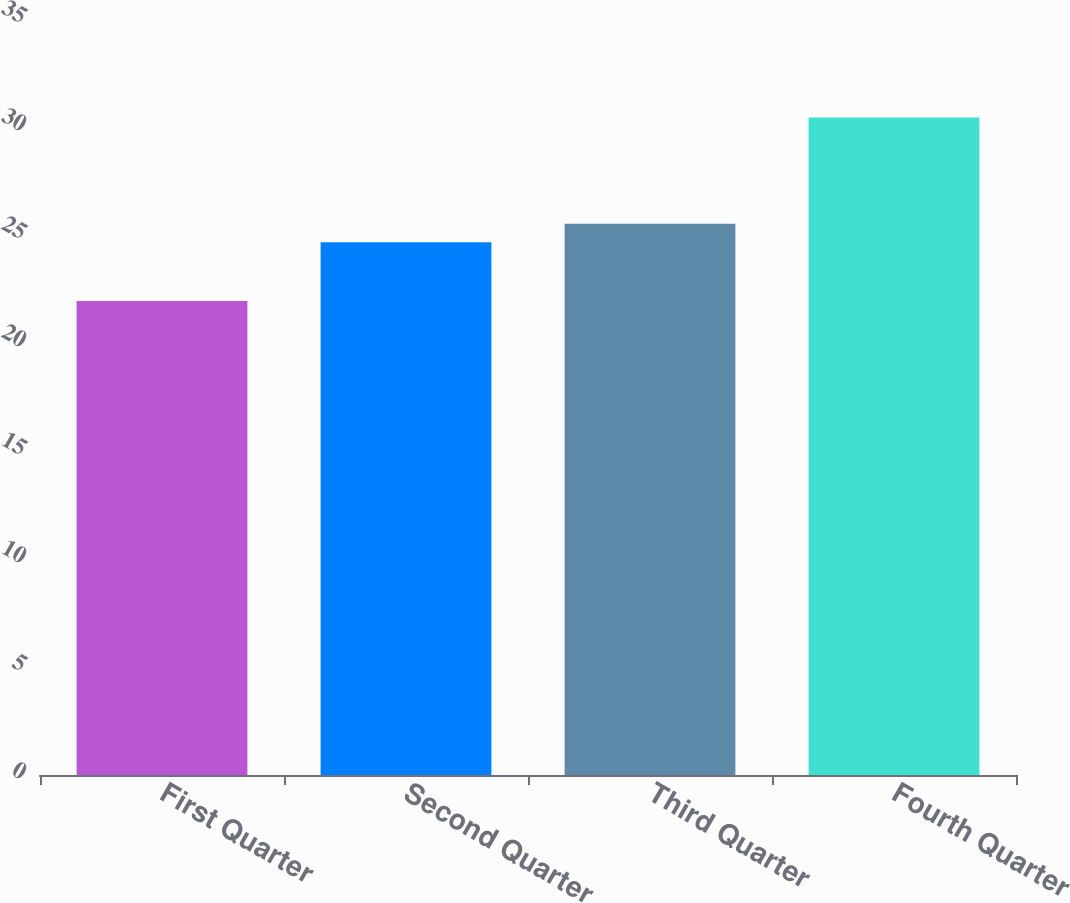Convert chart to OTSL. <chart><loc_0><loc_0><loc_500><loc_500><bar_chart><fcel>First Quarter<fcel>Second Quarter<fcel>Third Quarter<fcel>Fourth Quarter<nl><fcel>21.94<fcel>24.67<fcel>25.52<fcel>30.44<nl></chart> 